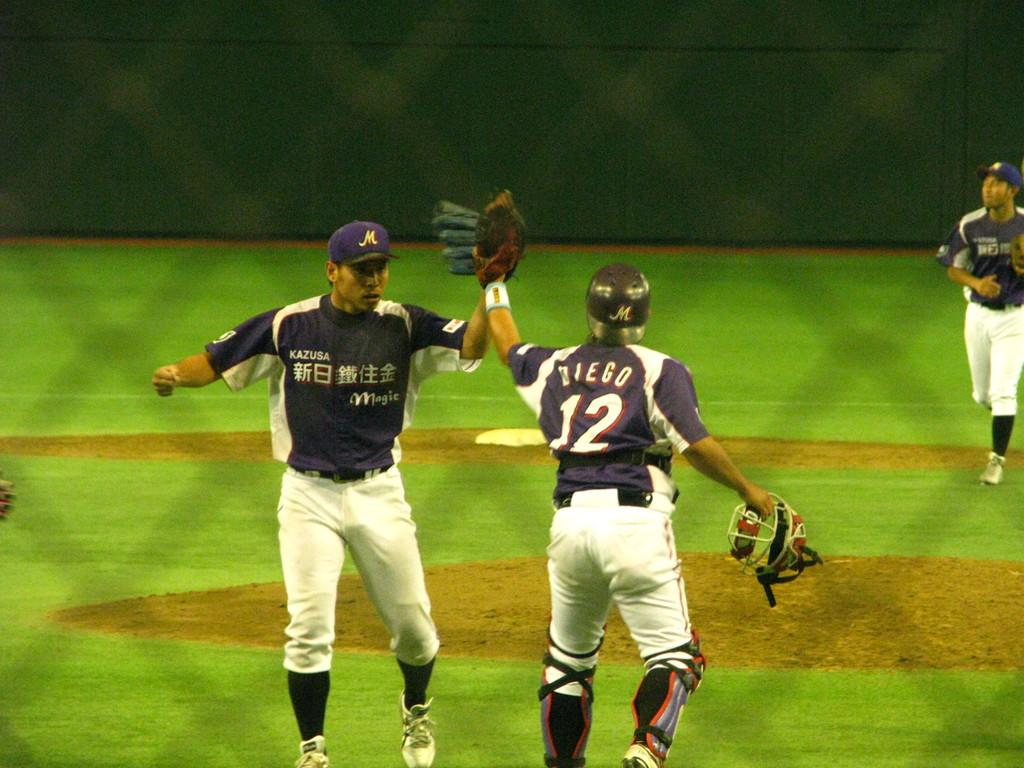<image>
Describe the image concisely. baseball player number 12 named diego taps gloves with another team player 